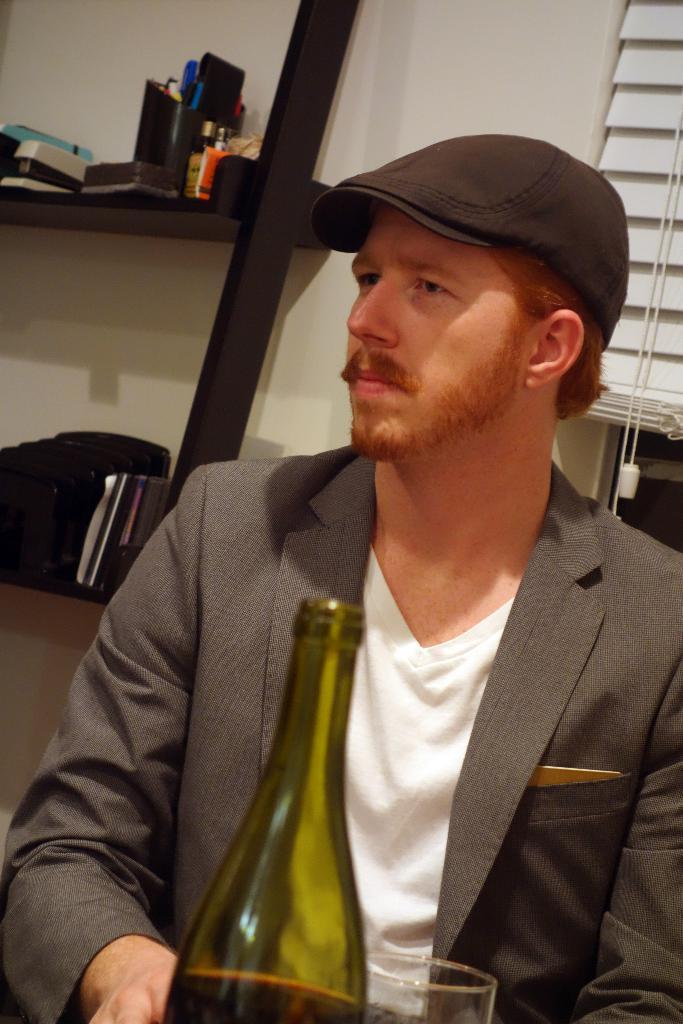Who is present in the image? There is a man in the image. What is in front of the man? There is a wine bottle and a wine glass in front of the man. What type of machine is being used by the man in the image? There is no machine present in the image; it only features a man, a wine bottle, and a wine glass. 